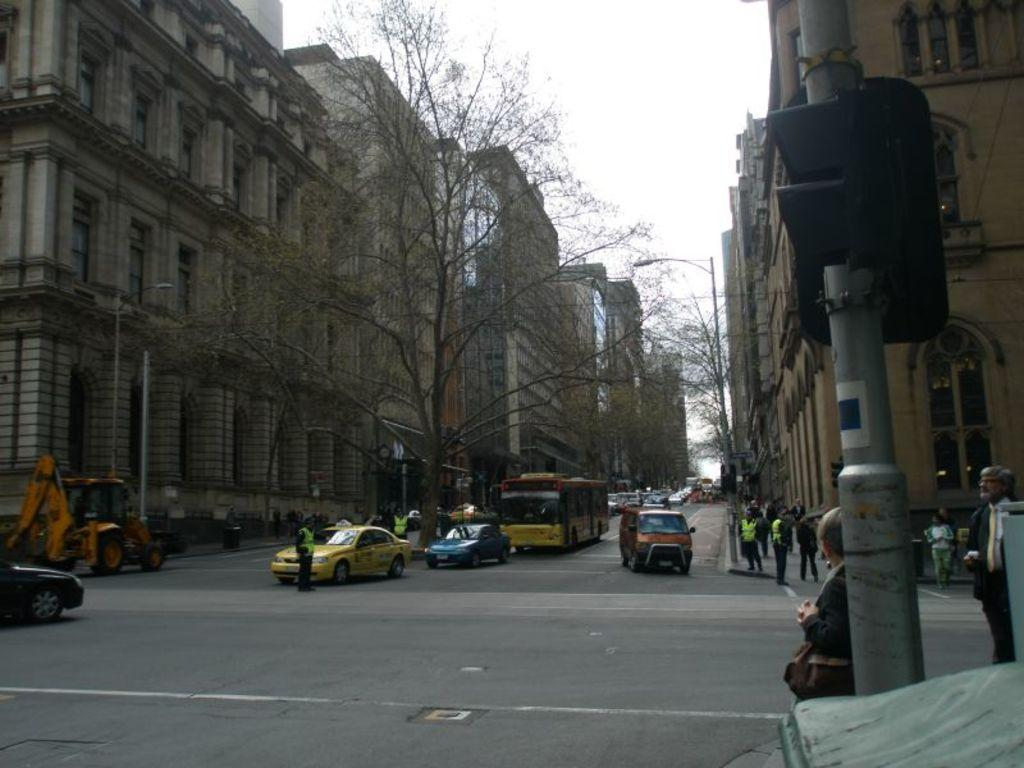What type of location is depicted in the image? There is a street in the image. What structures can be seen along the street? There are buildings along the street. What are some other objects present in the image? Street poles, street lights, motor vehicles, persons, an excavator, and traffic signals are visible in the image. What can be seen in the sky in the image? The sky is visible in the image. What type of lock is used to secure the value of the excavator in the image? There is no mention of a lock or value in the image; it simply shows an excavator as one of the objects present. Can you describe the laborer working on the street in the image? There is no laborer present in the image; the only persons mentioned are those walking on the road. 